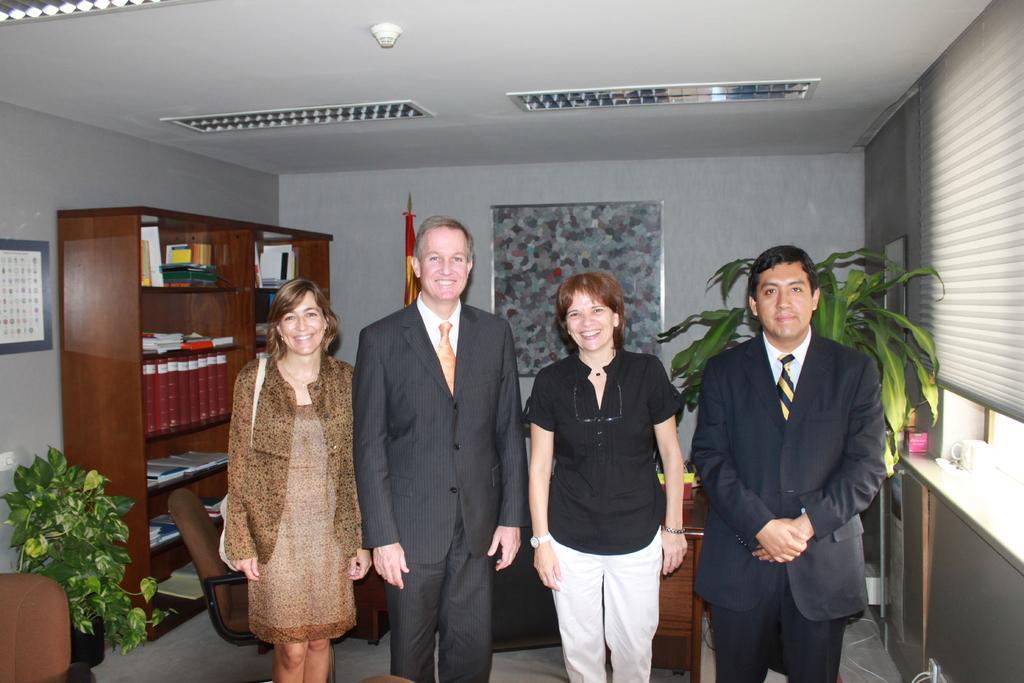Could you give a brief overview of what you see in this image? In this picture, there are four people standing in a row. Among them, there are two women and a man. Men are wearing blazers. One of the woman is wearing black top and another woman is wearing brown dress and carrying a bag. Towards the left, there is a plant and desk with books. Behind them, there is a flag and a frame to a wall. Towards the right, there is a plant and a window. 